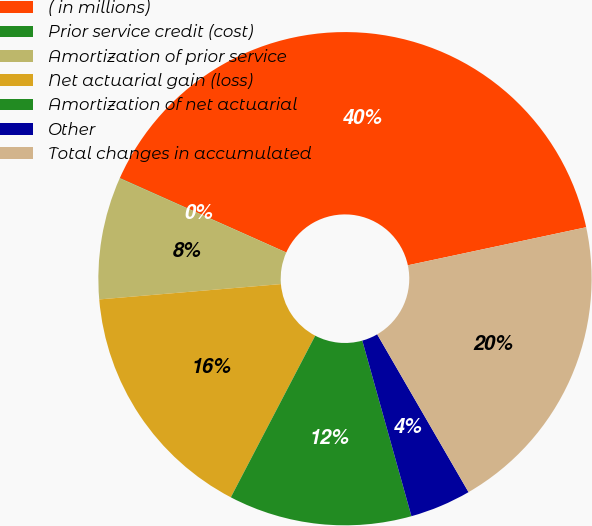Convert chart to OTSL. <chart><loc_0><loc_0><loc_500><loc_500><pie_chart><fcel>( in millions)<fcel>Prior service credit (cost)<fcel>Amortization of prior service<fcel>Net actuarial gain (loss)<fcel>Amortization of net actuarial<fcel>Other<fcel>Total changes in accumulated<nl><fcel>39.96%<fcel>0.02%<fcel>8.01%<fcel>16.0%<fcel>12.0%<fcel>4.01%<fcel>19.99%<nl></chart> 